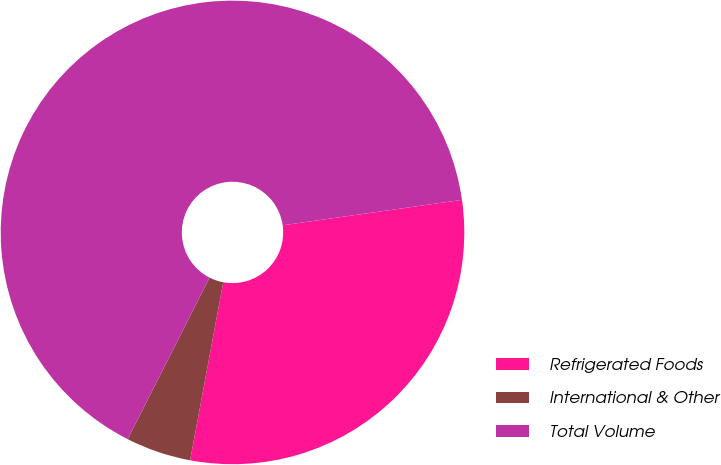Convert chart. <chart><loc_0><loc_0><loc_500><loc_500><pie_chart><fcel>Refrigerated Foods<fcel>International & Other<fcel>Total Volume<nl><fcel>30.17%<fcel>4.54%<fcel>65.29%<nl></chart> 